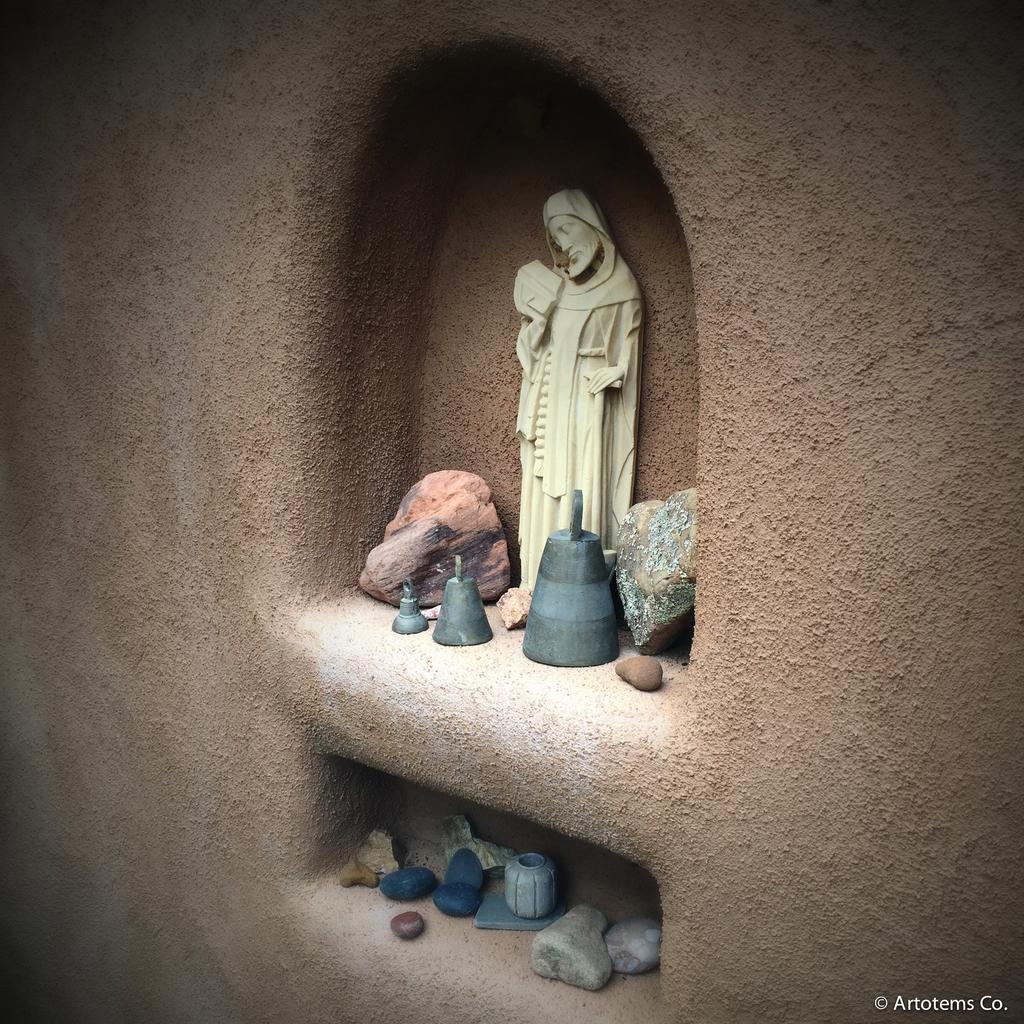Please provide a concise description of this image. In the picture I can see the wall, inside the wall we can see scepters, rocks are placed. 